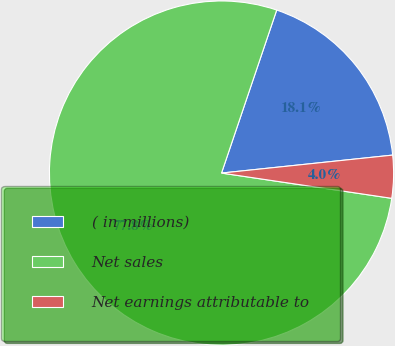<chart> <loc_0><loc_0><loc_500><loc_500><pie_chart><fcel>( in millions)<fcel>Net sales<fcel>Net earnings attributable to<nl><fcel>18.14%<fcel>77.85%<fcel>4.01%<nl></chart> 